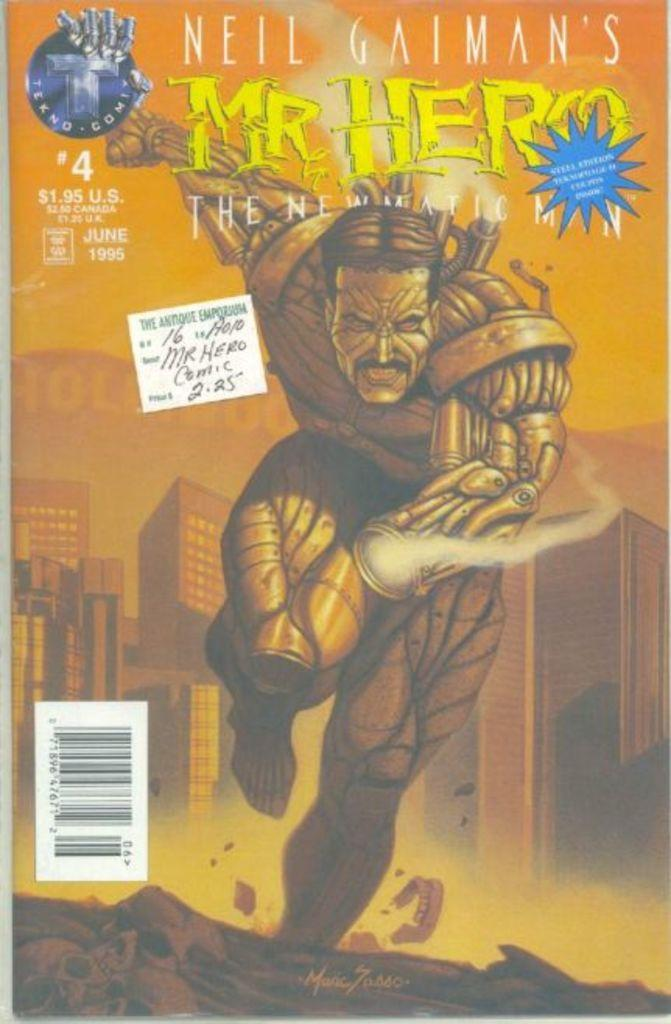<image>
Write a terse but informative summary of the picture. A Mr. Hero comic book is the fourth in a series. 